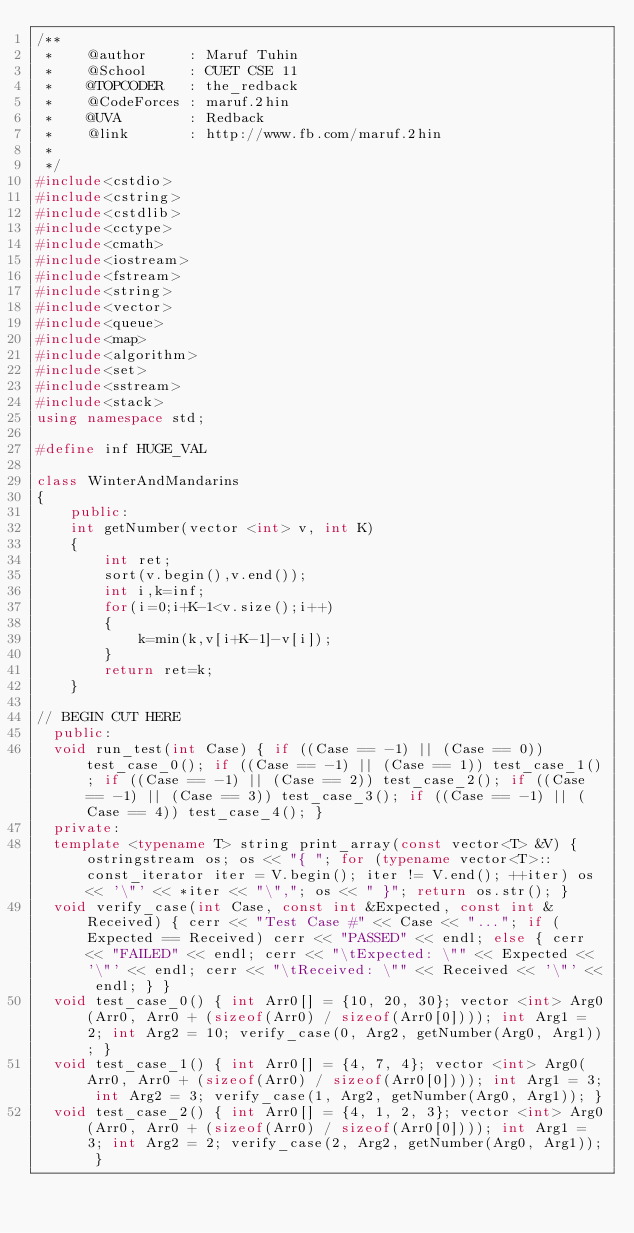<code> <loc_0><loc_0><loc_500><loc_500><_C++_>/**
 *    @author     : Maruf Tuhin
 *    @School     : CUET CSE 11
 *    @TOPCODER   : the_redback
 *    @CodeForces : maruf.2hin
 *    @UVA        : Redback
 *    @link       : http://www.fb.com/maruf.2hin
 *
 */
#include<cstdio>
#include<cstring>
#include<cstdlib>
#include<cctype>
#include<cmath>
#include<iostream>
#include<fstream>
#include<string>
#include<vector>
#include<queue>
#include<map>
#include<algorithm>
#include<set>
#include<sstream>
#include<stack>
using namespace std;

#define inf HUGE_VAL

class WinterAndMandarins
{
    public:
    int getNumber(vector <int> v, int K)
    {
        int ret;
        sort(v.begin(),v.end());
        int i,k=inf;
        for(i=0;i+K-1<v.size();i++)
        {
            k=min(k,v[i+K-1]-v[i]);
        }
        return ret=k;
    }

// BEGIN CUT HERE
	public:
	void run_test(int Case) { if ((Case == -1) || (Case == 0)) test_case_0(); if ((Case == -1) || (Case == 1)) test_case_1(); if ((Case == -1) || (Case == 2)) test_case_2(); if ((Case == -1) || (Case == 3)) test_case_3(); if ((Case == -1) || (Case == 4)) test_case_4(); }
	private:
	template <typename T> string print_array(const vector<T> &V) { ostringstream os; os << "{ "; for (typename vector<T>::const_iterator iter = V.begin(); iter != V.end(); ++iter) os << '\"' << *iter << "\","; os << " }"; return os.str(); }
	void verify_case(int Case, const int &Expected, const int &Received) { cerr << "Test Case #" << Case << "..."; if (Expected == Received) cerr << "PASSED" << endl; else { cerr << "FAILED" << endl; cerr << "\tExpected: \"" << Expected << '\"' << endl; cerr << "\tReceived: \"" << Received << '\"' << endl; } }
	void test_case_0() { int Arr0[] = {10, 20, 30}; vector <int> Arg0(Arr0, Arr0 + (sizeof(Arr0) / sizeof(Arr0[0]))); int Arg1 = 2; int Arg2 = 10; verify_case(0, Arg2, getNumber(Arg0, Arg1)); }
	void test_case_1() { int Arr0[] = {4, 7, 4}; vector <int> Arg0(Arr0, Arr0 + (sizeof(Arr0) / sizeof(Arr0[0]))); int Arg1 = 3; int Arg2 = 3; verify_case(1, Arg2, getNumber(Arg0, Arg1)); }
	void test_case_2() { int Arr0[] = {4, 1, 2, 3}; vector <int> Arg0(Arr0, Arr0 + (sizeof(Arr0) / sizeof(Arr0[0]))); int Arg1 = 3; int Arg2 = 2; verify_case(2, Arg2, getNumber(Arg0, Arg1)); }</code> 